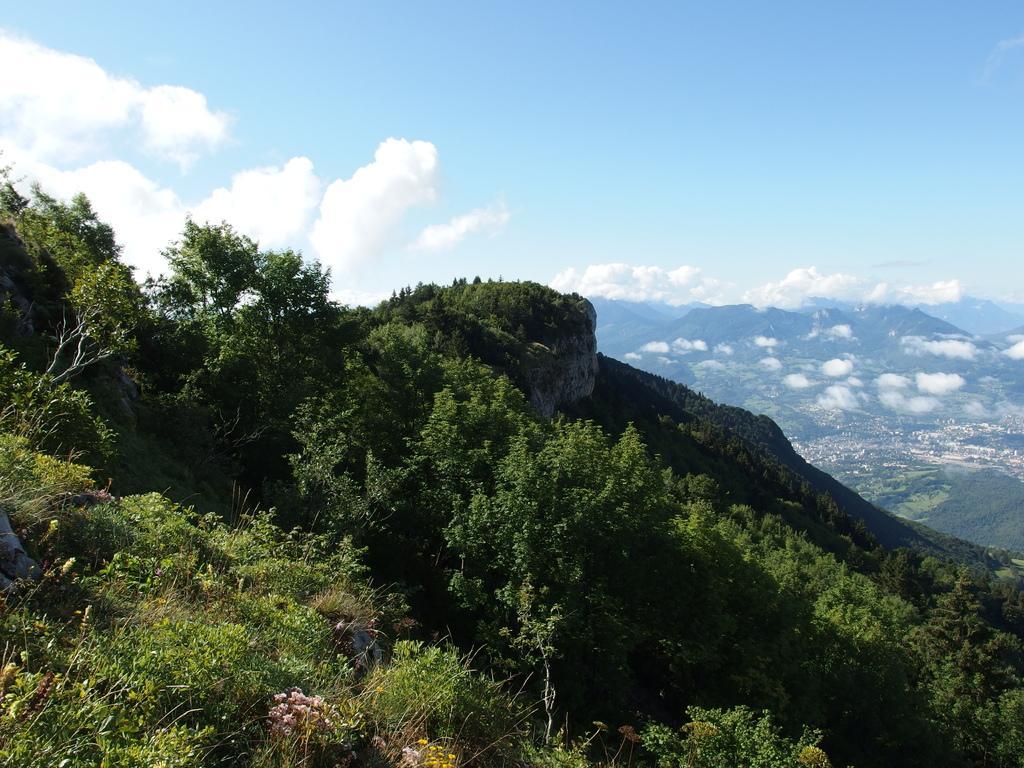In one or two sentences, can you explain what this image depicts? In this picture there is a beautiful view of the mountains with full of trees. Behind there is a mountain, blue sky and clouds. 